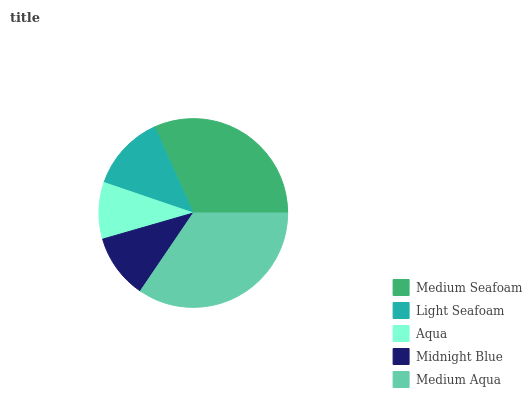Is Aqua the minimum?
Answer yes or no. Yes. Is Medium Aqua the maximum?
Answer yes or no. Yes. Is Light Seafoam the minimum?
Answer yes or no. No. Is Light Seafoam the maximum?
Answer yes or no. No. Is Medium Seafoam greater than Light Seafoam?
Answer yes or no. Yes. Is Light Seafoam less than Medium Seafoam?
Answer yes or no. Yes. Is Light Seafoam greater than Medium Seafoam?
Answer yes or no. No. Is Medium Seafoam less than Light Seafoam?
Answer yes or no. No. Is Light Seafoam the high median?
Answer yes or no. Yes. Is Light Seafoam the low median?
Answer yes or no. Yes. Is Medium Seafoam the high median?
Answer yes or no. No. Is Aqua the low median?
Answer yes or no. No. 